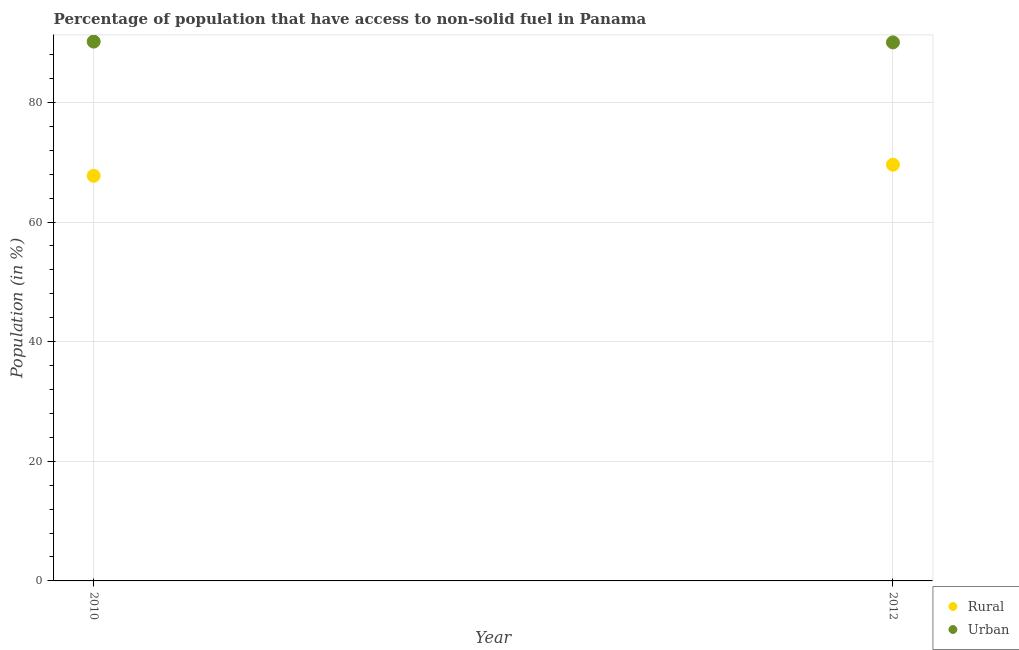What is the rural population in 2012?
Offer a very short reply. 69.59. Across all years, what is the maximum urban population?
Make the answer very short. 90.17. Across all years, what is the minimum rural population?
Provide a succinct answer. 67.73. In which year was the rural population maximum?
Your answer should be very brief. 2012. In which year was the urban population minimum?
Offer a terse response. 2012. What is the total urban population in the graph?
Provide a short and direct response. 180.19. What is the difference between the urban population in 2010 and that in 2012?
Your response must be concise. 0.14. What is the difference between the rural population in 2010 and the urban population in 2012?
Keep it short and to the point. -22.3. What is the average urban population per year?
Your answer should be compact. 90.1. In the year 2012, what is the difference between the urban population and rural population?
Offer a terse response. 20.44. What is the ratio of the urban population in 2010 to that in 2012?
Keep it short and to the point. 1. Is the rural population in 2010 less than that in 2012?
Provide a succinct answer. Yes. Is the urban population strictly less than the rural population over the years?
Your answer should be compact. No. How many dotlines are there?
Offer a terse response. 2. What is the difference between two consecutive major ticks on the Y-axis?
Ensure brevity in your answer.  20. Are the values on the major ticks of Y-axis written in scientific E-notation?
Your response must be concise. No. Does the graph contain any zero values?
Make the answer very short. No. How are the legend labels stacked?
Offer a terse response. Vertical. What is the title of the graph?
Your response must be concise. Percentage of population that have access to non-solid fuel in Panama. Does "Highest 20% of population" appear as one of the legend labels in the graph?
Your response must be concise. No. What is the label or title of the Y-axis?
Provide a succinct answer. Population (in %). What is the Population (in %) of Rural in 2010?
Keep it short and to the point. 67.73. What is the Population (in %) in Urban in 2010?
Your response must be concise. 90.17. What is the Population (in %) in Rural in 2012?
Provide a short and direct response. 69.59. What is the Population (in %) of Urban in 2012?
Keep it short and to the point. 90.03. Across all years, what is the maximum Population (in %) in Rural?
Make the answer very short. 69.59. Across all years, what is the maximum Population (in %) in Urban?
Ensure brevity in your answer.  90.17. Across all years, what is the minimum Population (in %) in Rural?
Offer a terse response. 67.73. Across all years, what is the minimum Population (in %) in Urban?
Ensure brevity in your answer.  90.03. What is the total Population (in %) in Rural in the graph?
Your answer should be compact. 137.32. What is the total Population (in %) of Urban in the graph?
Your answer should be compact. 180.19. What is the difference between the Population (in %) of Rural in 2010 and that in 2012?
Provide a succinct answer. -1.85. What is the difference between the Population (in %) of Urban in 2010 and that in 2012?
Your response must be concise. 0.14. What is the difference between the Population (in %) of Rural in 2010 and the Population (in %) of Urban in 2012?
Your answer should be compact. -22.3. What is the average Population (in %) in Rural per year?
Your response must be concise. 68.66. What is the average Population (in %) in Urban per year?
Offer a terse response. 90.1. In the year 2010, what is the difference between the Population (in %) in Rural and Population (in %) in Urban?
Make the answer very short. -22.43. In the year 2012, what is the difference between the Population (in %) of Rural and Population (in %) of Urban?
Keep it short and to the point. -20.44. What is the ratio of the Population (in %) of Rural in 2010 to that in 2012?
Ensure brevity in your answer.  0.97. What is the ratio of the Population (in %) in Urban in 2010 to that in 2012?
Your answer should be compact. 1. What is the difference between the highest and the second highest Population (in %) of Rural?
Your response must be concise. 1.85. What is the difference between the highest and the second highest Population (in %) of Urban?
Keep it short and to the point. 0.14. What is the difference between the highest and the lowest Population (in %) of Rural?
Keep it short and to the point. 1.85. What is the difference between the highest and the lowest Population (in %) of Urban?
Your response must be concise. 0.14. 